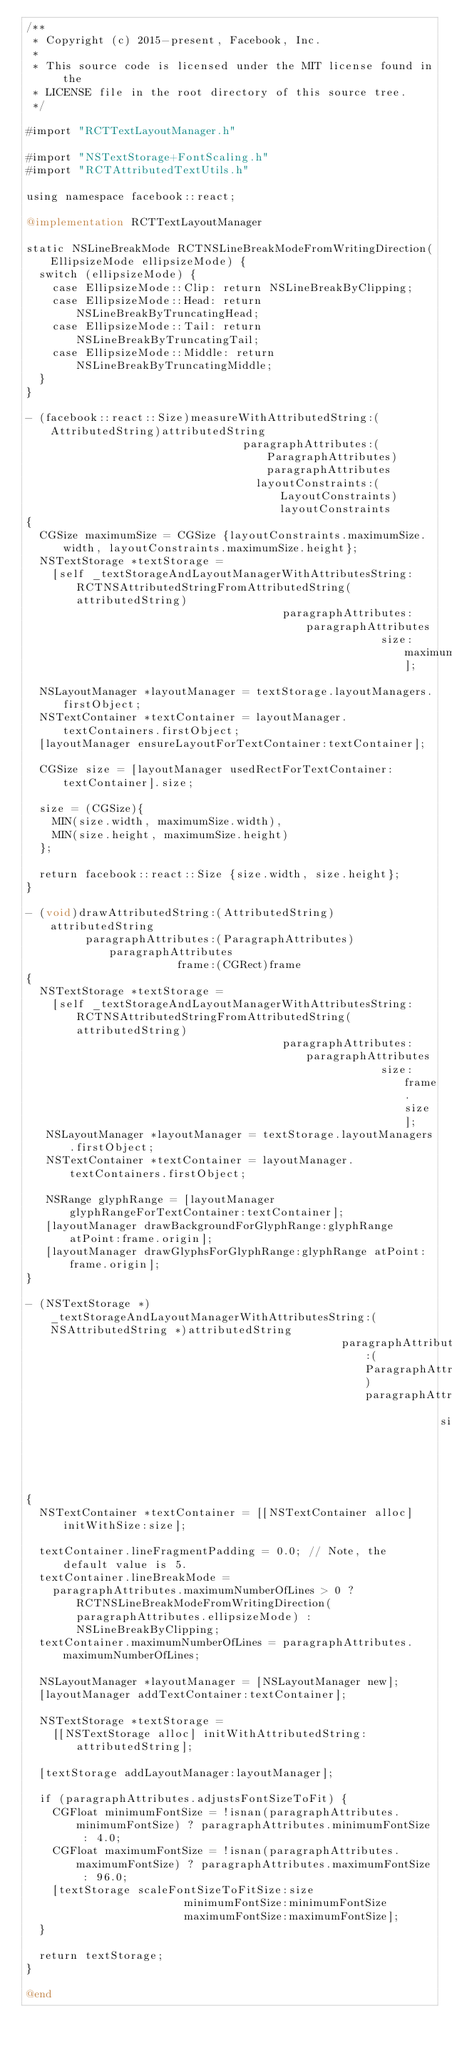<code> <loc_0><loc_0><loc_500><loc_500><_ObjectiveC_>/**
 * Copyright (c) 2015-present, Facebook, Inc.
 *
 * This source code is licensed under the MIT license found in the
 * LICENSE file in the root directory of this source tree.
 */

#import "RCTTextLayoutManager.h"

#import "NSTextStorage+FontScaling.h"
#import "RCTAttributedTextUtils.h"

using namespace facebook::react;

@implementation RCTTextLayoutManager

static NSLineBreakMode RCTNSLineBreakModeFromWritingDirection(EllipsizeMode ellipsizeMode) {
  switch (ellipsizeMode) {
    case EllipsizeMode::Clip: return NSLineBreakByClipping;
    case EllipsizeMode::Head: return NSLineBreakByTruncatingHead;
    case EllipsizeMode::Tail: return NSLineBreakByTruncatingTail;
    case EllipsizeMode::Middle: return NSLineBreakByTruncatingMiddle;
  }
}

- (facebook::react::Size)measureWithAttributedString:(AttributedString)attributedString
                                 paragraphAttributes:(ParagraphAttributes)paragraphAttributes
                                   layoutConstraints:(LayoutConstraints)layoutConstraints
{
  CGSize maximumSize = CGSize {layoutConstraints.maximumSize.width, layoutConstraints.maximumSize.height};
  NSTextStorage *textStorage =
    [self _textStorageAndLayoutManagerWithAttributesString:RCTNSAttributedStringFromAttributedString(attributedString)
                                       paragraphAttributes:paragraphAttributes
                                                      size:maximumSize];

  NSLayoutManager *layoutManager = textStorage.layoutManagers.firstObject;
  NSTextContainer *textContainer = layoutManager.textContainers.firstObject;
  [layoutManager ensureLayoutForTextContainer:textContainer];

  CGSize size = [layoutManager usedRectForTextContainer:textContainer].size;

  size = (CGSize){
    MIN(size.width, maximumSize.width),
    MIN(size.height, maximumSize.height)
  };

  return facebook::react::Size {size.width, size.height};
}

- (void)drawAttributedString:(AttributedString)attributedString
         paragraphAttributes:(ParagraphAttributes)paragraphAttributes
                       frame:(CGRect)frame
{
  NSTextStorage *textStorage =
    [self _textStorageAndLayoutManagerWithAttributesString:RCTNSAttributedStringFromAttributedString(attributedString)
                                       paragraphAttributes:paragraphAttributes
                                                      size:frame.size];
   NSLayoutManager *layoutManager = textStorage.layoutManagers.firstObject;
   NSTextContainer *textContainer = layoutManager.textContainers.firstObject;

   NSRange glyphRange = [layoutManager glyphRangeForTextContainer:textContainer];
   [layoutManager drawBackgroundForGlyphRange:glyphRange atPoint:frame.origin];
   [layoutManager drawGlyphsForGlyphRange:glyphRange atPoint:frame.origin];
}

- (NSTextStorage *)_textStorageAndLayoutManagerWithAttributesString:(NSAttributedString *)attributedString
                                                paragraphAttributes:(ParagraphAttributes)paragraphAttributes
                                                               size:(CGSize)size
{
  NSTextContainer *textContainer = [[NSTextContainer alloc] initWithSize:size];

  textContainer.lineFragmentPadding = 0.0; // Note, the default value is 5.
  textContainer.lineBreakMode =
    paragraphAttributes.maximumNumberOfLines > 0 ? RCTNSLineBreakModeFromWritingDirection(paragraphAttributes.ellipsizeMode) : NSLineBreakByClipping;
  textContainer.maximumNumberOfLines = paragraphAttributes.maximumNumberOfLines;

  NSLayoutManager *layoutManager = [NSLayoutManager new];
  [layoutManager addTextContainer:textContainer];

  NSTextStorage *textStorage =
    [[NSTextStorage alloc] initWithAttributedString:attributedString];

  [textStorage addLayoutManager:layoutManager];

  if (paragraphAttributes.adjustsFontSizeToFit) {
    CGFloat minimumFontSize = !isnan(paragraphAttributes.minimumFontSize) ? paragraphAttributes.minimumFontSize : 4.0;
    CGFloat maximumFontSize = !isnan(paragraphAttributes.maximumFontSize) ? paragraphAttributes.maximumFontSize : 96.0;
    [textStorage scaleFontSizeToFitSize:size
                        minimumFontSize:minimumFontSize
                        maximumFontSize:maximumFontSize];
  }

  return textStorage;
}

@end
</code> 